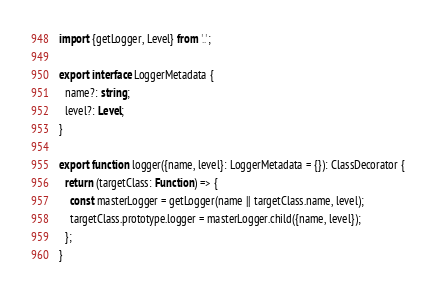<code> <loc_0><loc_0><loc_500><loc_500><_TypeScript_>import {getLogger, Level} from '..';

export interface LoggerMetadata {
  name?: string;
  level?: Level;
}

export function logger({name, level}: LoggerMetadata = {}): ClassDecorator {
  return (targetClass: Function) => {
    const masterLogger = getLogger(name || targetClass.name, level);
    targetClass.prototype.logger = masterLogger.child({name, level});
  };
}
</code> 